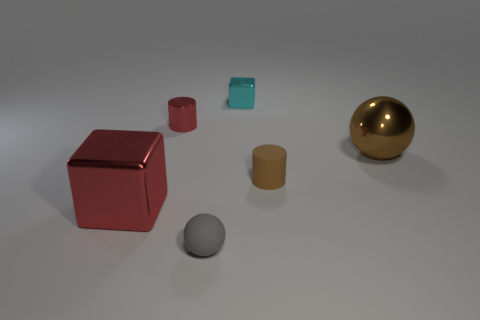There is a object that is the same color as the small matte cylinder; what is its size?
Provide a succinct answer. Large. There is a large metallic thing that is behind the brown cylinder; is its shape the same as the small brown object?
Provide a short and direct response. No. What number of big brown metal things are there?
Your response must be concise. 1. How many metal spheres have the same size as the red metallic block?
Provide a succinct answer. 1. What is the material of the big brown object?
Your answer should be compact. Metal. There is a small shiny cylinder; does it have the same color as the shiny cube that is in front of the small cyan thing?
Ensure brevity in your answer.  Yes. There is a thing that is both left of the gray sphere and in front of the large brown ball; what is its size?
Make the answer very short. Large. What is the shape of the small object that is the same material as the gray ball?
Offer a terse response. Cylinder. Are the gray object and the cylinder on the right side of the metallic cylinder made of the same material?
Your answer should be compact. Yes. Are there any cylinders in front of the matte thing to the left of the tiny cyan cube?
Keep it short and to the point. No. 